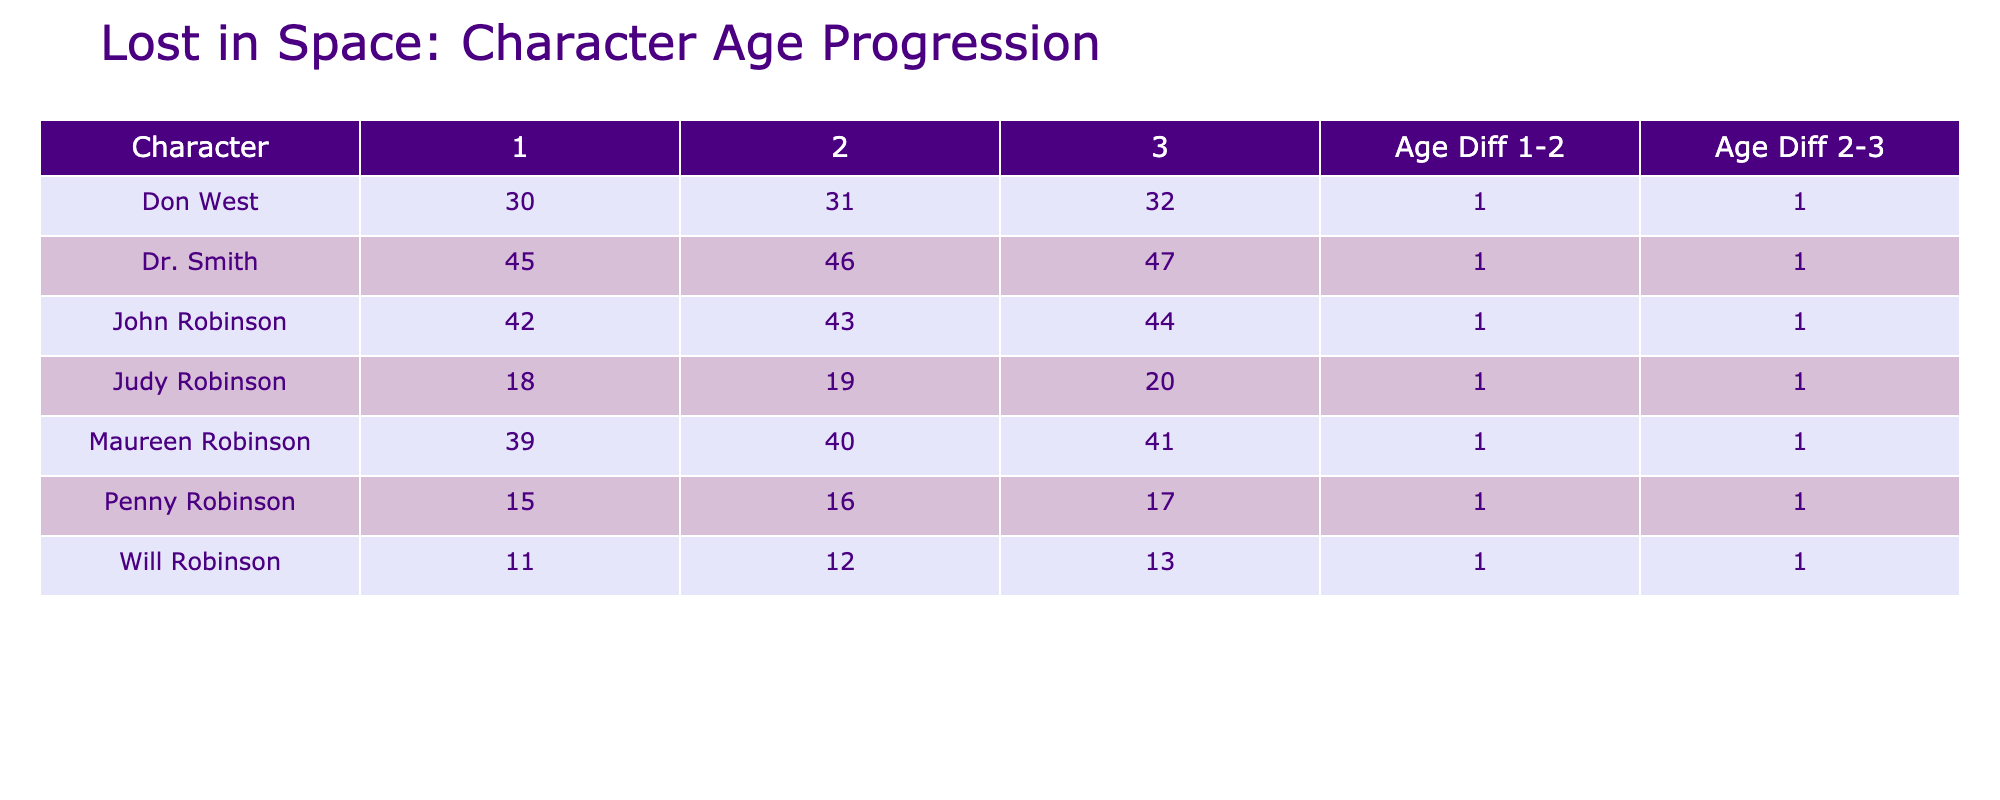What is the age of Judy Robinson in Season 1? Looking at the table, under the column for Season 1, the row for Judy Robinson shows her age is 18.
Answer: 18 What is the age difference of Will Robinson from Season 1 to Season 2? In Season 1, Will Robinson is 11 years old, and in Season 2, he is 12. Therefore, the age difference is 12 - 11 = 1.
Answer: 1 Is Dr. Smith older than John Robinson in Season 3? Dr. Smith is 47 years old in Season 3, while John Robinson is 44 years old. Since 47 > 44, the answer is yes.
Answer: Yes What are the ages of Maureen Robinson across all seasons? In the table, Maureen Robinson's ages are listed as 39 in Season 1, 40 in Season 2, and 41 in Season 3.
Answer: 39, 40, 41 What is the average age of the Robinson family in Season 2? The ages of the Robinson family in Season 2 are John (43), Maureen (40), Judy (19), Penny (16), and Will (12), summing these gives 43 + 40 + 19 + 16 + 12 = 130. To find the average, divide by 5. The average is thus 130 / 5 = 26.
Answer: 26 What is the maximum age difference between the characters between Seasons 1 and 3? In Season 1, the oldest character is Dr. Smith at 45. In Season 3, the oldest is again Dr. Smith at 47. The maximum difference stays as 47 - 45 = 2 years for Dr. Smith.
Answer: 2 Was John Robinson 42 years old in any season? Referring to the table, John Robinson is indeed 42 years old in Season 1, which confirms the statement as true.
Answer: Yes How many characters have age differences increase as we move from Season 1 to Season 3? Examining the table, only two characters show an increase in age: John Robinson (42 to 44) and Judy Robinson (18 to 20), thus, the total is 2 characters.
Answer: 2 Which character had the greatest age leap between Season 1 and Season 3? Looking at the ages, Dr. Smith went from 45 to 47, which is a leap of 2 years. The others either increased by 1 year or less, marking Dr. Smith with the greatest leap.
Answer: Dr. Smith 